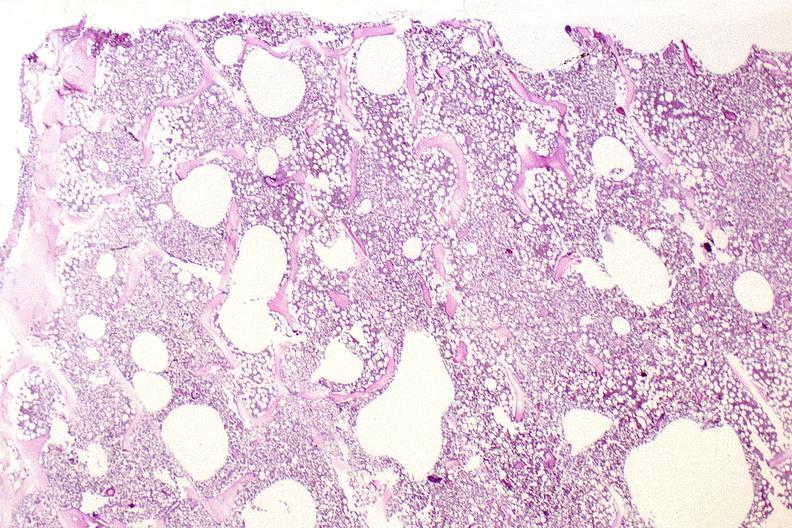s musculoskeletal present?
Answer the question using a single word or phrase. Yes 